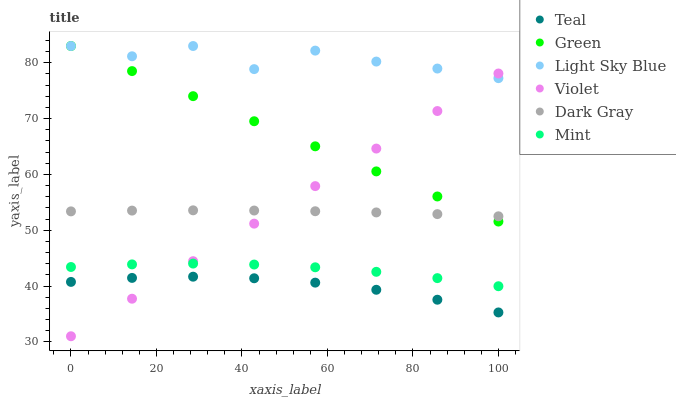Does Teal have the minimum area under the curve?
Answer yes or no. Yes. Does Light Sky Blue have the maximum area under the curve?
Answer yes or no. Yes. Does Green have the minimum area under the curve?
Answer yes or no. No. Does Green have the maximum area under the curve?
Answer yes or no. No. Is Violet the smoothest?
Answer yes or no. Yes. Is Light Sky Blue the roughest?
Answer yes or no. Yes. Is Green the smoothest?
Answer yes or no. No. Is Green the roughest?
Answer yes or no. No. Does Violet have the lowest value?
Answer yes or no. Yes. Does Green have the lowest value?
Answer yes or no. No. Does Green have the highest value?
Answer yes or no. Yes. Does Teal have the highest value?
Answer yes or no. No. Is Teal less than Green?
Answer yes or no. Yes. Is Light Sky Blue greater than Dark Gray?
Answer yes or no. Yes. Does Green intersect Violet?
Answer yes or no. Yes. Is Green less than Violet?
Answer yes or no. No. Is Green greater than Violet?
Answer yes or no. No. Does Teal intersect Green?
Answer yes or no. No. 